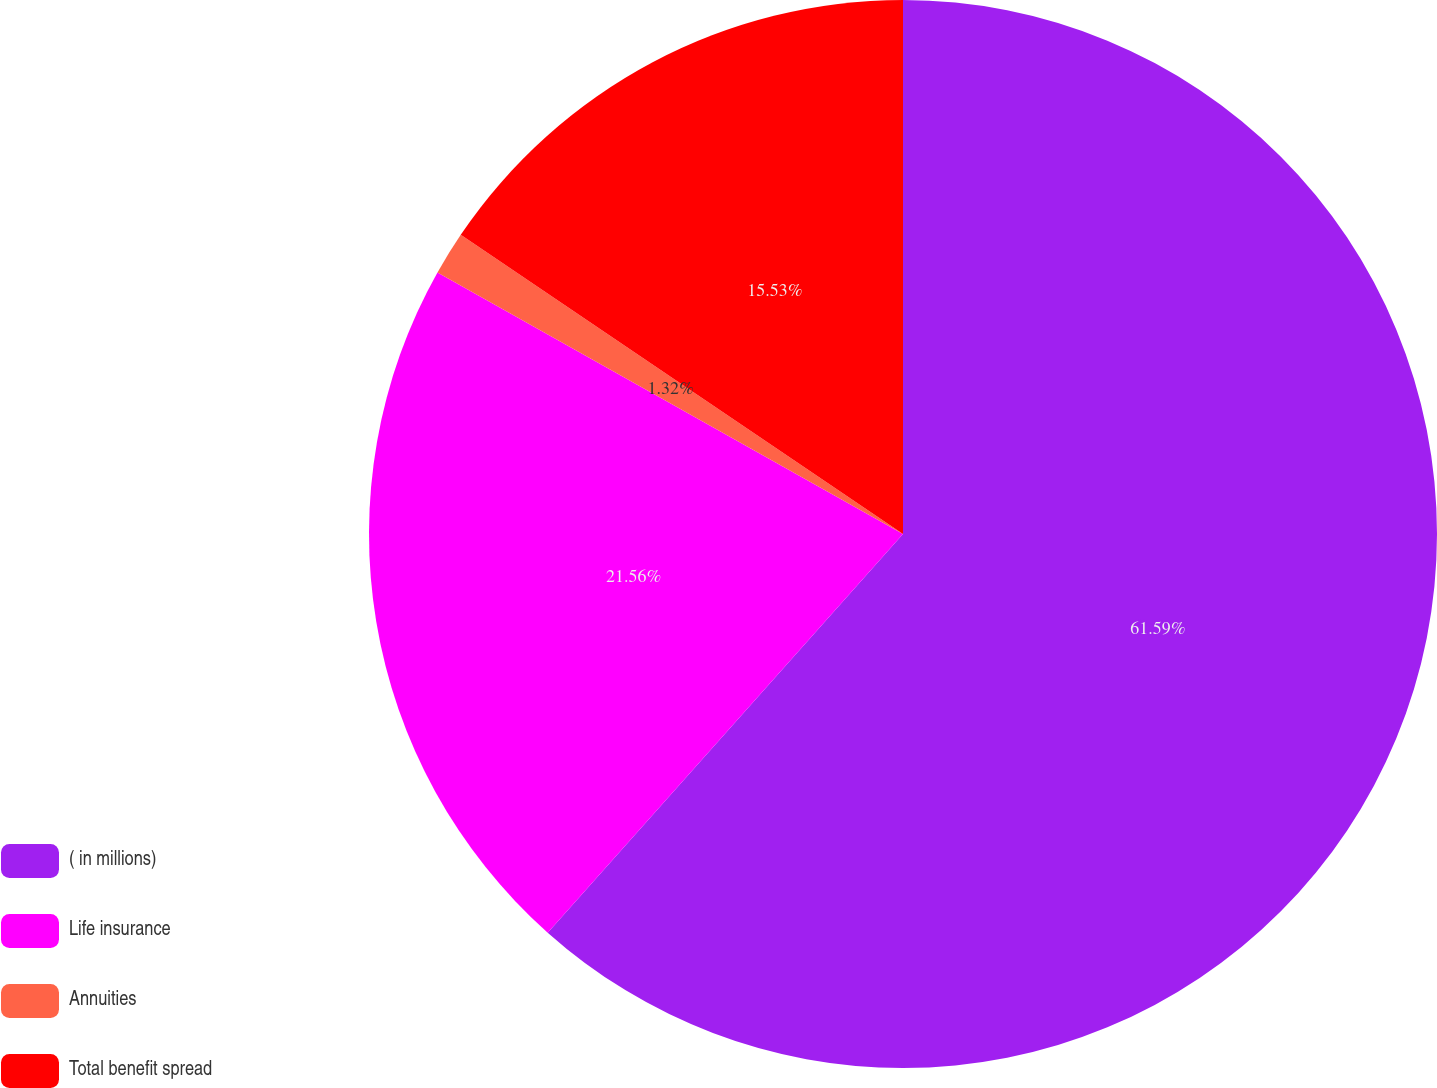<chart> <loc_0><loc_0><loc_500><loc_500><pie_chart><fcel>( in millions)<fcel>Life insurance<fcel>Annuities<fcel>Total benefit spread<nl><fcel>61.58%<fcel>21.56%<fcel>1.32%<fcel>15.53%<nl></chart> 